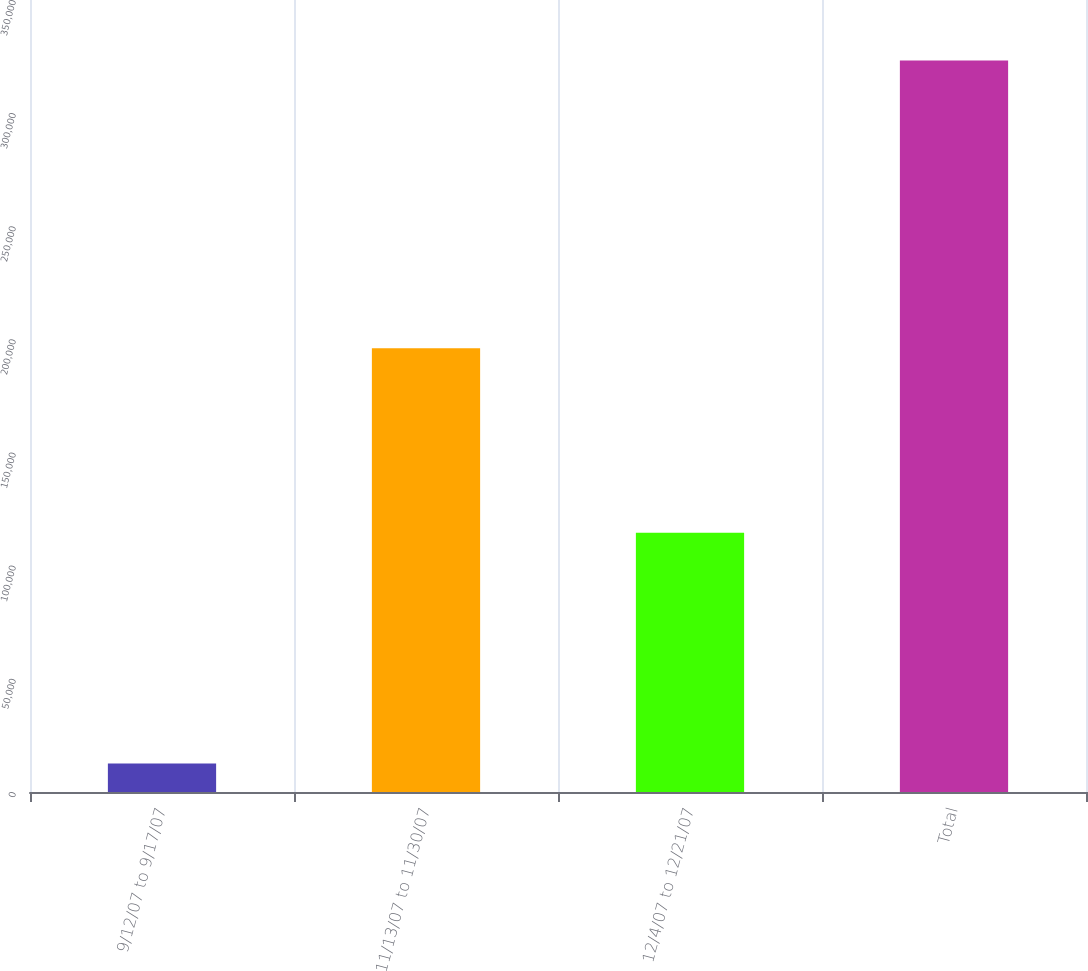Convert chart to OTSL. <chart><loc_0><loc_0><loc_500><loc_500><bar_chart><fcel>9/12/07 to 9/17/07<fcel>11/13/07 to 11/30/07<fcel>12/4/07 to 12/21/07<fcel>Total<nl><fcel>12600<fcel>196059<fcel>114600<fcel>323259<nl></chart> 